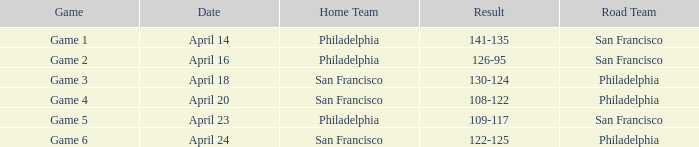What occurred in the april 16 contest? 126-95. 